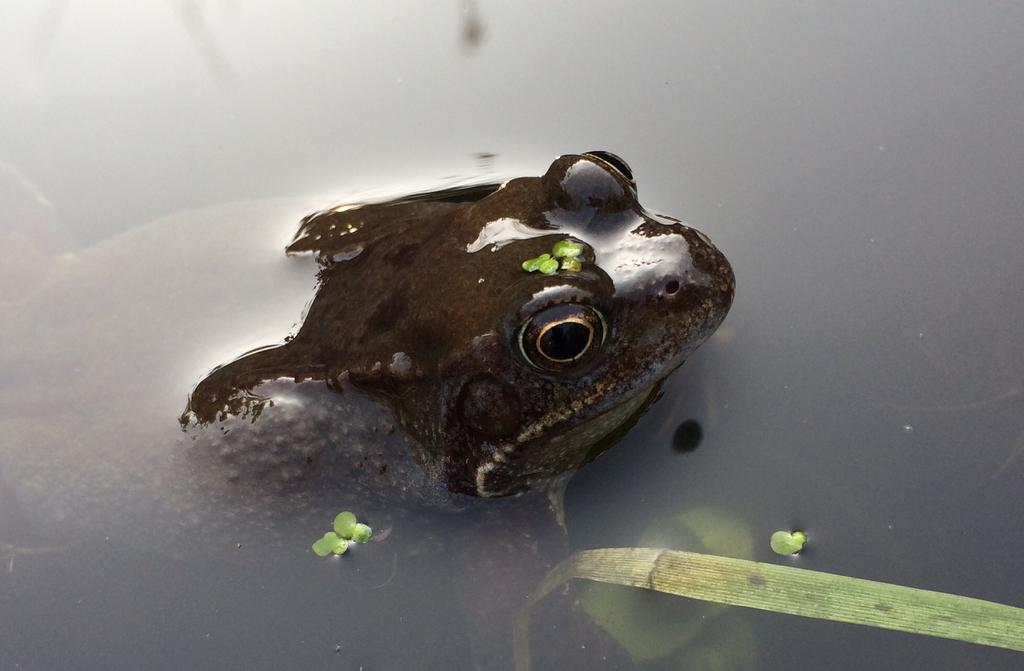What is the primary element in the image? There is water in the image. What type of animal can be seen in the water? There is a frog in the water. Are there any plants visible in the image? Yes, there is a water plant in the image. What type of square apparel is the frog wearing in the image? There is no apparel visible on the frog in the image, and the frog is not wearing any square items. 